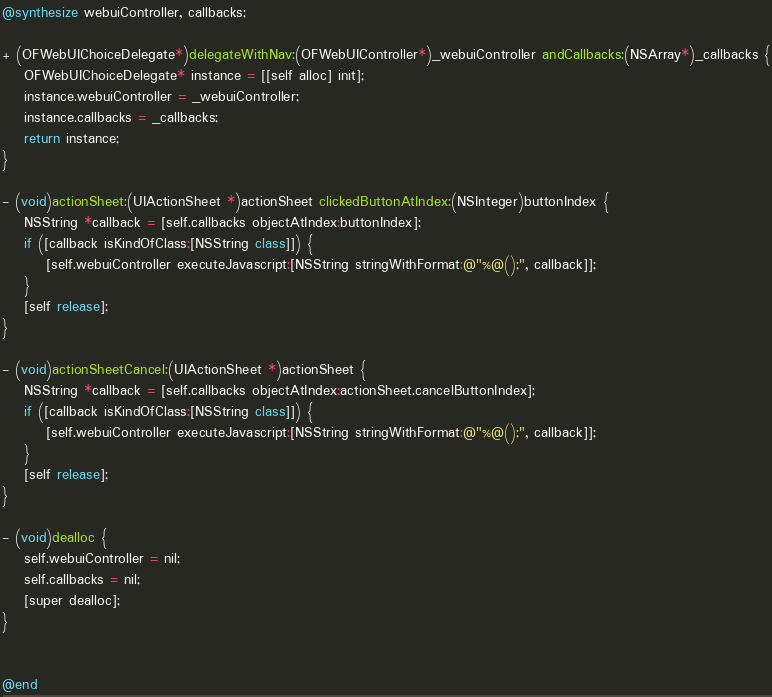Convert code to text. <code><loc_0><loc_0><loc_500><loc_500><_ObjectiveC_>@synthesize webuiController, callbacks;

+ (OFWebUIChoiceDelegate*)delegateWithNav:(OFWebUIController*)_webuiController andCallbacks:(NSArray*)_callbacks {
	OFWebUIChoiceDelegate* instance = [[self alloc] init];
	instance.webuiController = _webuiController;
	instance.callbacks = _callbacks;
	return instance;
}

- (void)actionSheet:(UIActionSheet *)actionSheet clickedButtonAtIndex:(NSInteger)buttonIndex {
    NSString *callback = [self.callbacks objectAtIndex:buttonIndex];
    if ([callback isKindOfClass:[NSString class]]) {
		[self.webuiController executeJavascript:[NSString stringWithFormat:@"%@();", callback]];
	}
	[self release];
}

- (void)actionSheetCancel:(UIActionSheet *)actionSheet {
    NSString *callback = [self.callbacks objectAtIndex:actionSheet.cancelButtonIndex];
    if ([callback isKindOfClass:[NSString class]]) {
		[self.webuiController executeJavascript:[NSString stringWithFormat:@"%@();", callback]];
	}
	[self release];
}

- (void)dealloc {
    self.webuiController = nil;
    self.callbacks = nil;
    [super dealloc];
}


@end
</code> 